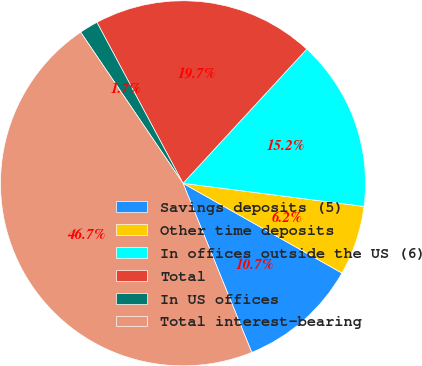Convert chart to OTSL. <chart><loc_0><loc_0><loc_500><loc_500><pie_chart><fcel>Savings deposits (5)<fcel>Other time deposits<fcel>In offices outside the US (6)<fcel>Total<fcel>In US offices<fcel>Total interest-bearing<nl><fcel>10.67%<fcel>6.16%<fcel>15.17%<fcel>19.67%<fcel>1.66%<fcel>46.67%<nl></chart> 